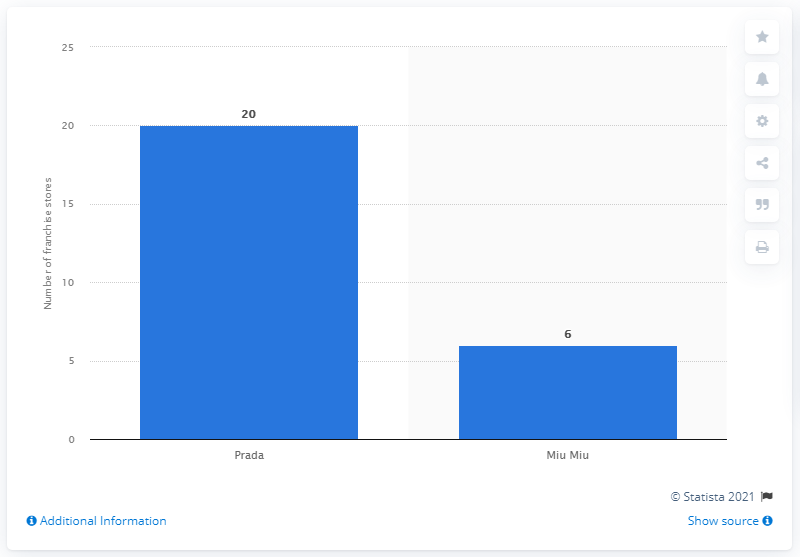Identify some key points in this picture. As of 2020, Prada owned a total of 20 franchised stores. As of our knowledge cutoff date of September 2021, the Prada Group owned a total of 26 stores worldwide. The number of Prada stores operated by the group is 20. 